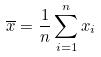<formula> <loc_0><loc_0><loc_500><loc_500>\overline { x } = \frac { 1 } { n } \sum _ { i = 1 } ^ { n } x _ { i }</formula> 